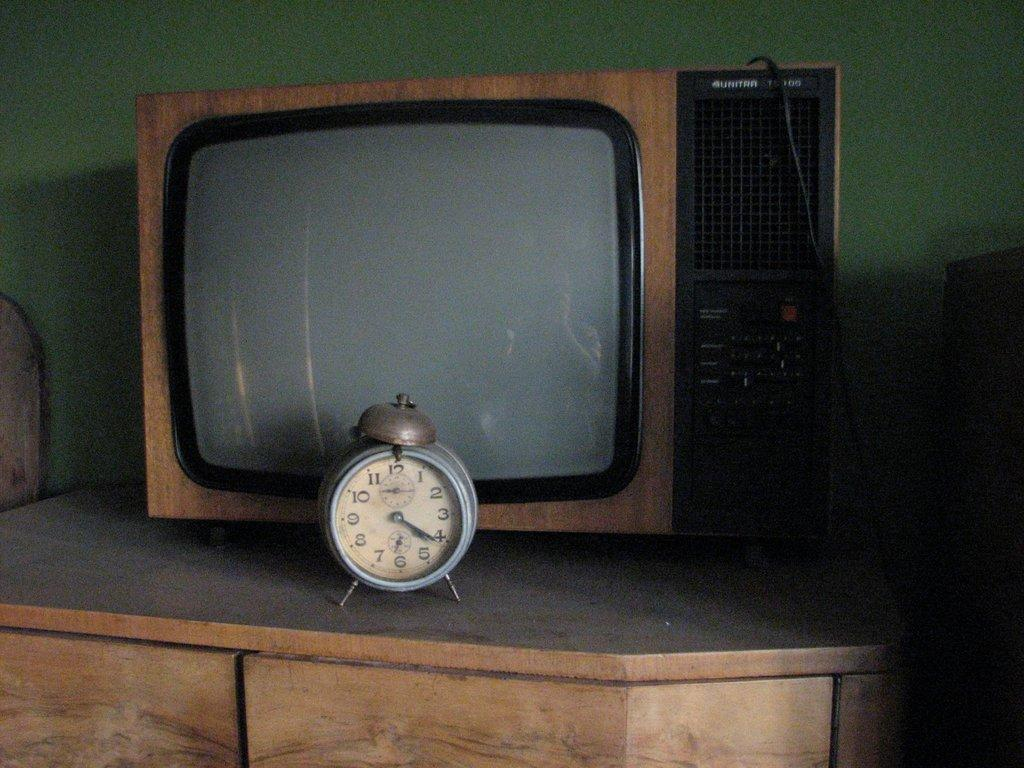<image>
Create a compact narrative representing the image presented. An alarm clock sits in front of a television and shows a time of 4:20. 